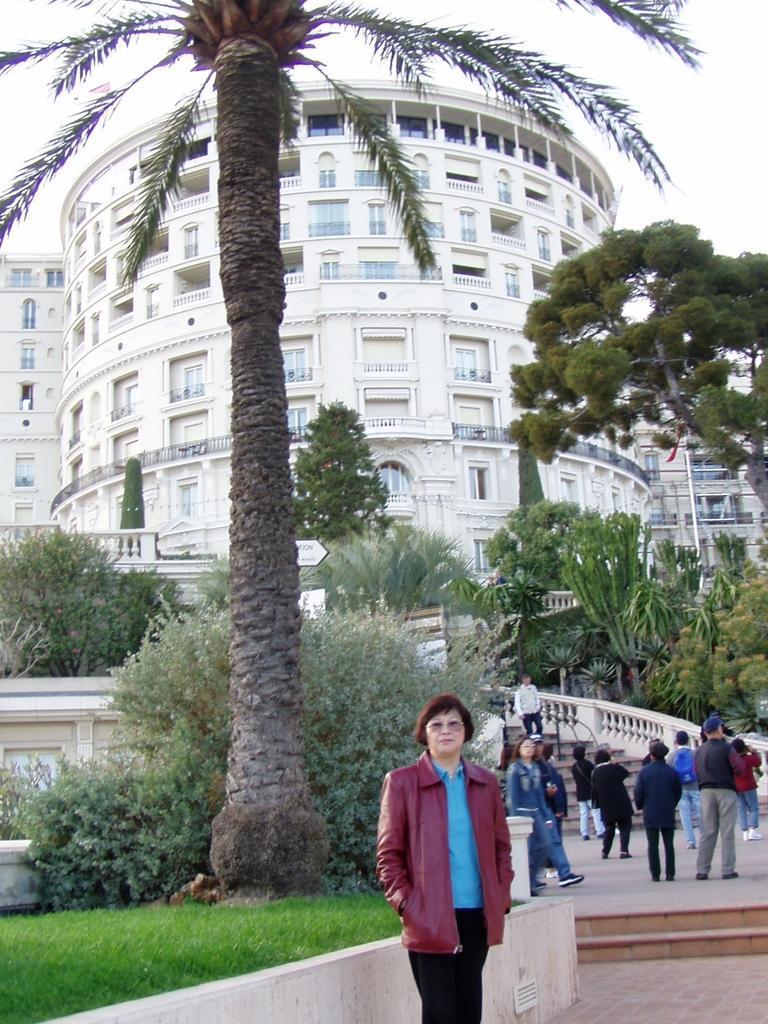Could you give a brief overview of what you see in this image? In this image we can see few buildings and they are having many windows. There are many trees and plants in the image. There are staircases in the image. There are many people in the image. There is a sky in the image. 